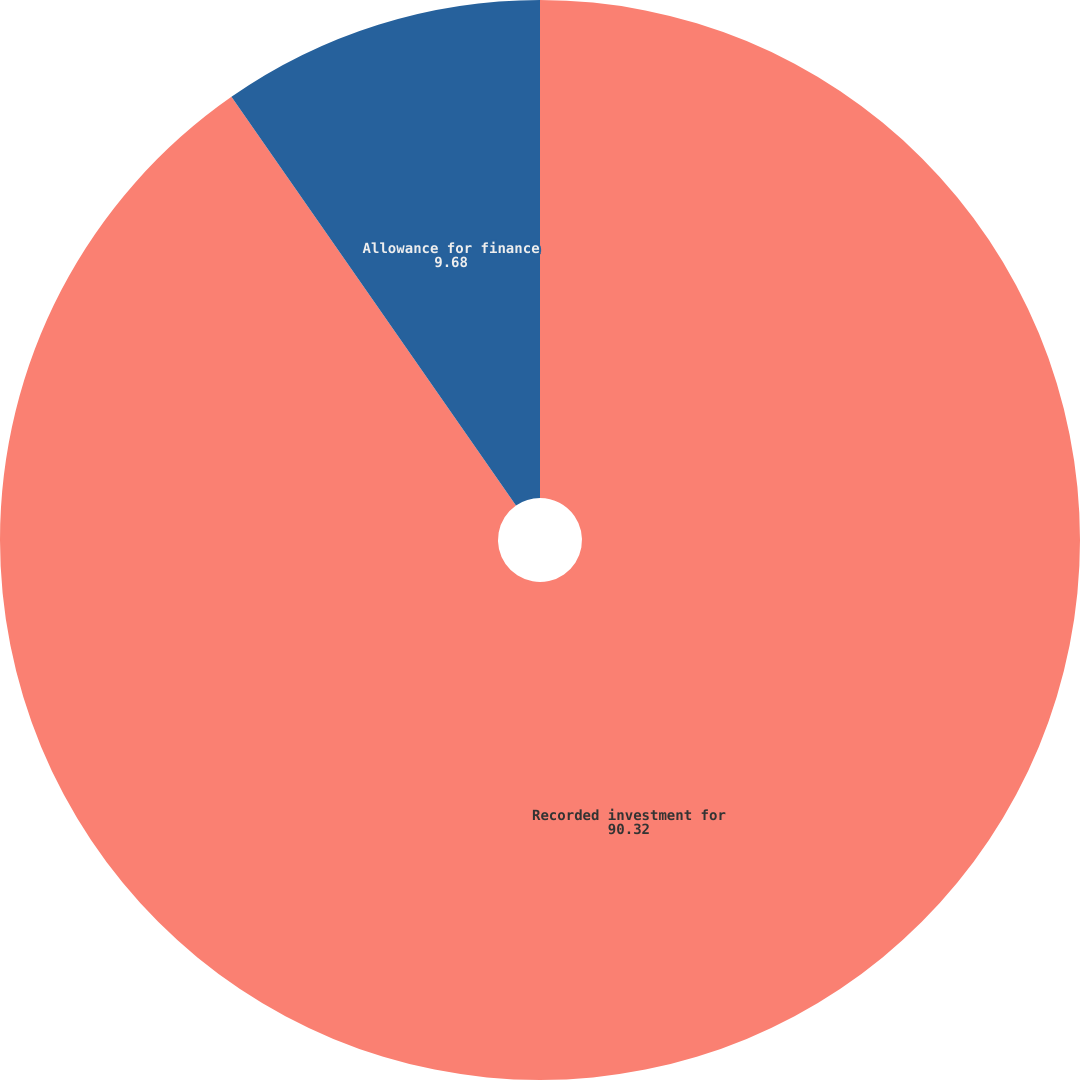<chart> <loc_0><loc_0><loc_500><loc_500><pie_chart><fcel>Recorded investment for<fcel>Allowance for finance<nl><fcel>90.32%<fcel>9.68%<nl></chart> 